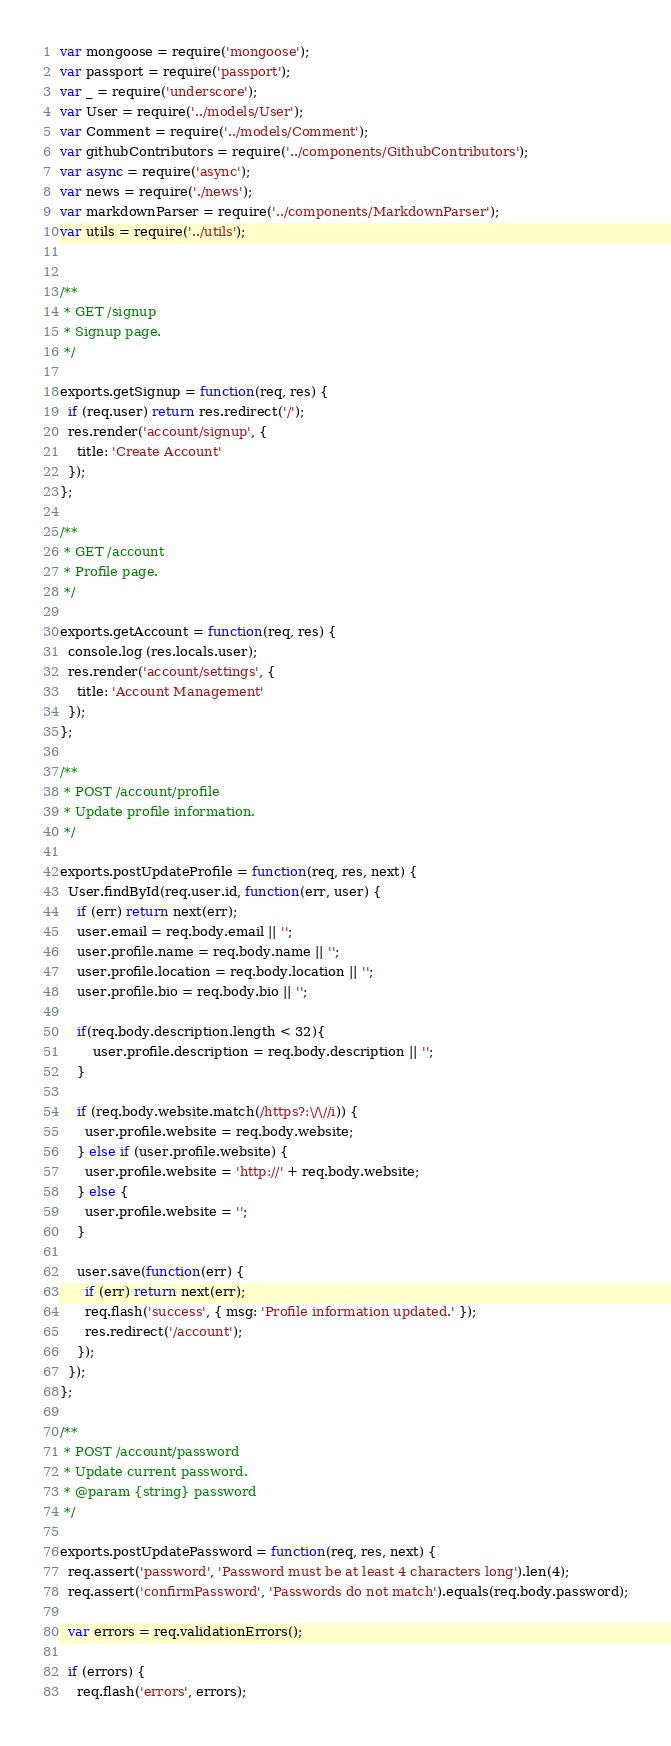<code> <loc_0><loc_0><loc_500><loc_500><_JavaScript_>var mongoose = require('mongoose');
var passport = require('passport');
var _ = require('underscore');
var User = require('../models/User');
var Comment = require('../models/Comment');
var githubContributors = require('../components/GithubContributors');
var async = require('async');
var news = require('./news');
var markdownParser = require('../components/MarkdownParser');
var utils = require('../utils');


/**
 * GET /signup
 * Signup page.
 */

exports.getSignup = function(req, res) {
  if (req.user) return res.redirect('/');
  res.render('account/signup', {
    title: 'Create Account'
  });
};

/**
 * GET /account
 * Profile page.
 */

exports.getAccount = function(req, res) {
  console.log (res.locals.user);
  res.render('account/settings', {
    title: 'Account Management'
  });
};

/**
 * POST /account/profile
 * Update profile information.
 */

exports.postUpdateProfile = function(req, res, next) {
  User.findById(req.user.id, function(err, user) {
    if (err) return next(err);
    user.email = req.body.email || '';
    user.profile.name = req.body.name || '';
    user.profile.location = req.body.location || '';
    user.profile.bio = req.body.bio || '';

    if(req.body.description.length < 32){  
        user.profile.description = req.body.description || '';
    }

    if (req.body.website.match(/https?:\/\//i)) {
      user.profile.website = req.body.website;
    } else if (user.profile.website) {
      user.profile.website = 'http://' + req.body.website;
    } else {
      user.profile.website = '';
    }

    user.save(function(err) {
      if (err) return next(err);
      req.flash('success', { msg: 'Profile information updated.' });
      res.redirect('/account');
    });
  });
};

/**
 * POST /account/password
 * Update current password.
 * @param {string} password
 */

exports.postUpdatePassword = function(req, res, next) {
  req.assert('password', 'Password must be at least 4 characters long').len(4);
  req.assert('confirmPassword', 'Passwords do not match').equals(req.body.password);

  var errors = req.validationErrors();

  if (errors) {
    req.flash('errors', errors);</code> 